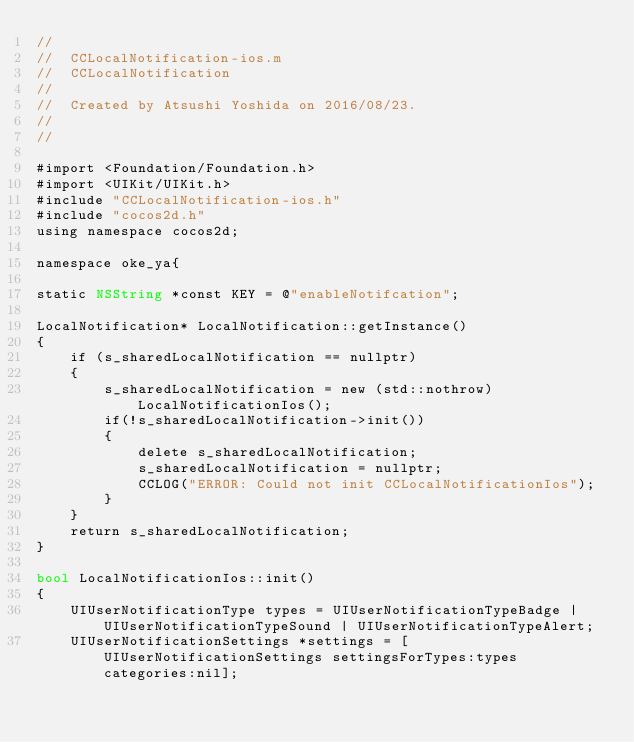Convert code to text. <code><loc_0><loc_0><loc_500><loc_500><_ObjectiveC_>//
//  CCLocalNotification-ios.m
//  CCLocalNotification
//
//  Created by Atsushi Yoshida on 2016/08/23.
//
//

#import <Foundation/Foundation.h>
#import <UIKit/UIKit.h>
#include "CCLocalNotification-ios.h"
#include "cocos2d.h"
using namespace cocos2d;

namespace oke_ya{

static NSString *const KEY = @"enableNotifcation";
    
LocalNotification* LocalNotification::getInstance()
{
    if (s_sharedLocalNotification == nullptr)
    {
        s_sharedLocalNotification = new (std::nothrow) LocalNotificationIos();
        if(!s_sharedLocalNotification->init())
        {
            delete s_sharedLocalNotification;
            s_sharedLocalNotification = nullptr;
            CCLOG("ERROR: Could not init CCLocalNotificationIos");
        }
    }
    return s_sharedLocalNotification;
}

bool LocalNotificationIos::init()
{
    UIUserNotificationType types = UIUserNotificationTypeBadge | UIUserNotificationTypeSound | UIUserNotificationTypeAlert;
    UIUserNotificationSettings *settings = [UIUserNotificationSettings settingsForTypes:types categories:nil];</code> 